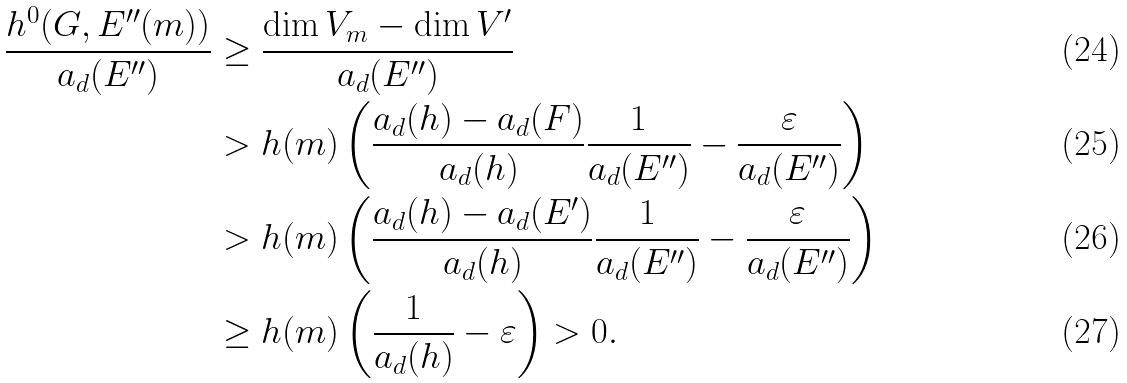<formula> <loc_0><loc_0><loc_500><loc_500>\frac { h ^ { 0 } ( G , E ^ { \prime \prime } ( m ) ) } { a _ { d } ( E ^ { \prime \prime } ) } & \geq \frac { \dim V _ { m } - \dim V ^ { \prime } } { a _ { d } ( E ^ { \prime \prime } ) } \\ & > h ( m ) \left ( \frac { a _ { d } ( h ) - a _ { d } ( F ) } { a _ { d } ( h ) } \frac { 1 } { a _ { d } ( E ^ { \prime \prime } ) } - \frac { \varepsilon } { a _ { d } ( E ^ { \prime \prime } ) } \right ) \\ & > h ( m ) \left ( \frac { a _ { d } ( h ) - a _ { d } ( E ^ { \prime } ) } { a _ { d } ( h ) } \frac { 1 } { a _ { d } ( E ^ { \prime \prime } ) } - \frac { \varepsilon } { a _ { d } ( E ^ { \prime \prime } ) } \right ) \\ & \geq h ( m ) \left ( \frac { 1 } { a _ { d } ( h ) } - \varepsilon \right ) > 0 .</formula> 